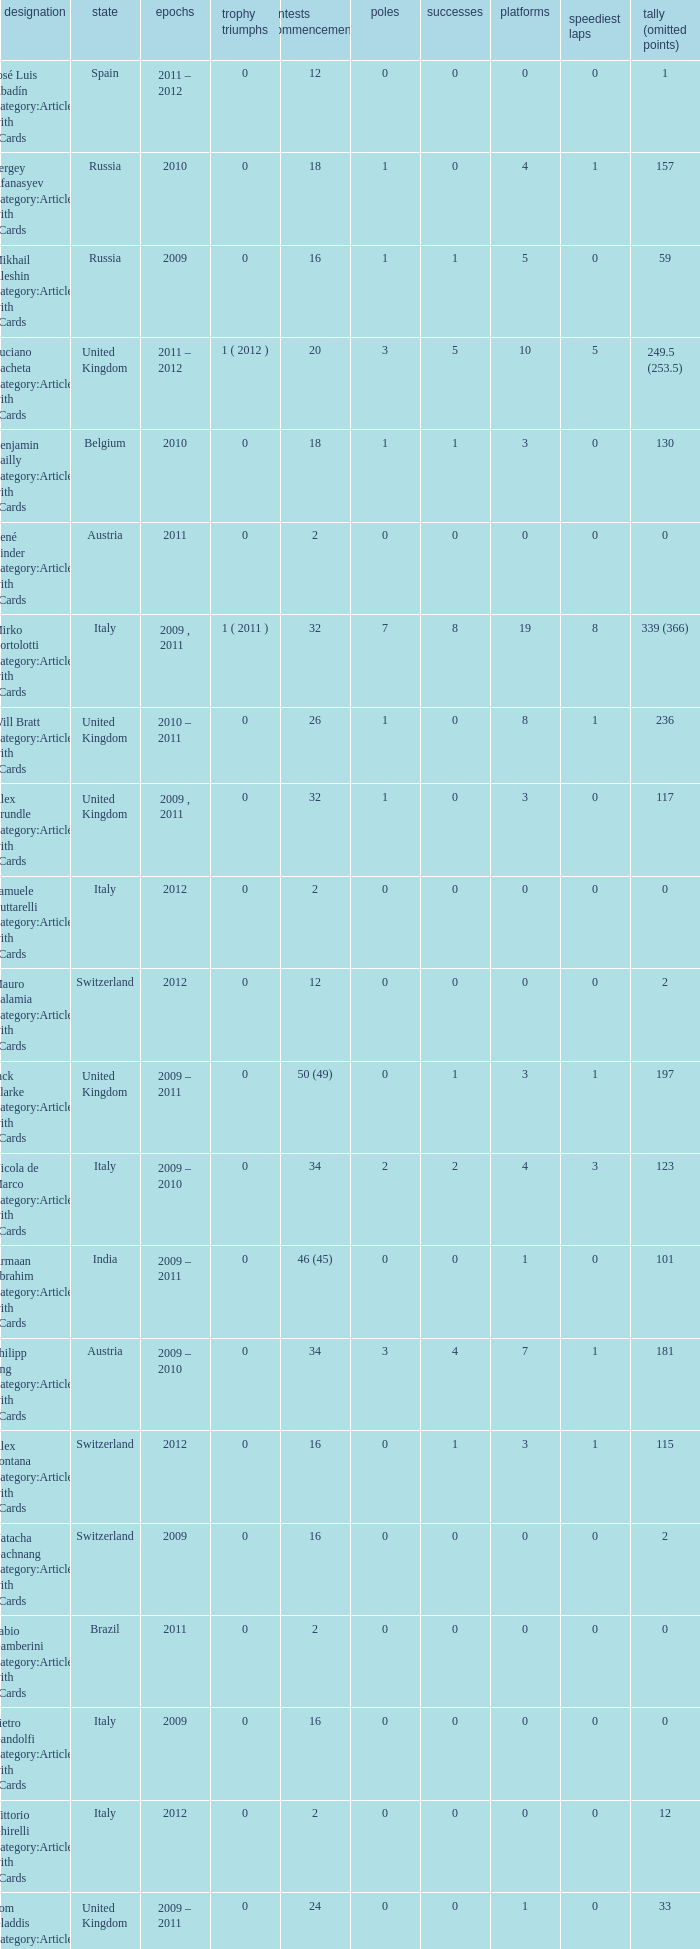What is the minimum amount of poles? 0.0. 